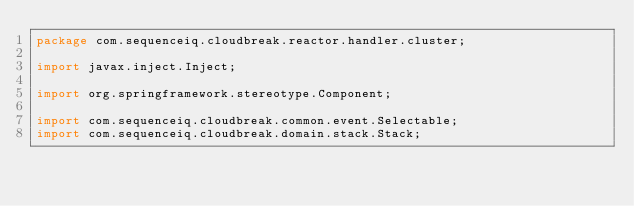Convert code to text. <code><loc_0><loc_0><loc_500><loc_500><_Java_>package com.sequenceiq.cloudbreak.reactor.handler.cluster;

import javax.inject.Inject;

import org.springframework.stereotype.Component;

import com.sequenceiq.cloudbreak.common.event.Selectable;
import com.sequenceiq.cloudbreak.domain.stack.Stack;</code> 